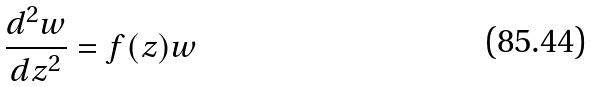<formula> <loc_0><loc_0><loc_500><loc_500>\frac { d ^ { 2 } w } { d z ^ { 2 } } = f ( z ) w</formula> 